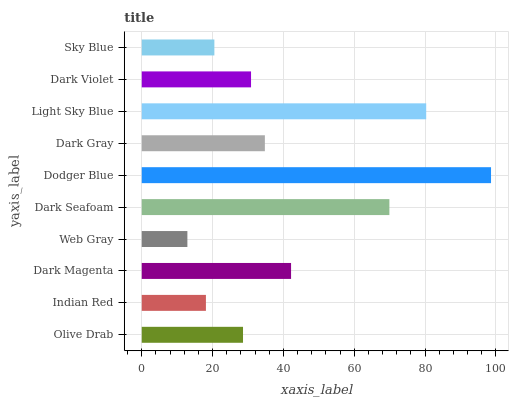Is Web Gray the minimum?
Answer yes or no. Yes. Is Dodger Blue the maximum?
Answer yes or no. Yes. Is Indian Red the minimum?
Answer yes or no. No. Is Indian Red the maximum?
Answer yes or no. No. Is Olive Drab greater than Indian Red?
Answer yes or no. Yes. Is Indian Red less than Olive Drab?
Answer yes or no. Yes. Is Indian Red greater than Olive Drab?
Answer yes or no. No. Is Olive Drab less than Indian Red?
Answer yes or no. No. Is Dark Gray the high median?
Answer yes or no. Yes. Is Dark Violet the low median?
Answer yes or no. Yes. Is Light Sky Blue the high median?
Answer yes or no. No. Is Dark Seafoam the low median?
Answer yes or no. No. 